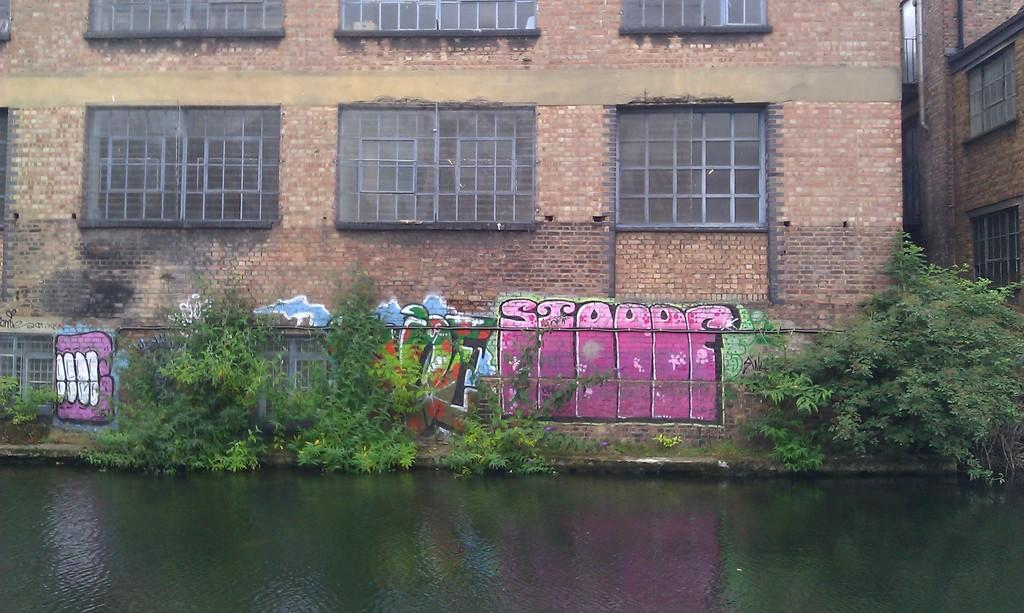What is at the bottom of the image? There is water at the bottom of the image. What can be seen growing in the image? There are plants visible in the image. What type of structures are in the background of the image? There are buildings in the background of the image. What type of berry can be smelled in the image? There is no berry present in the image, and therefore no smell can be associated with it. 